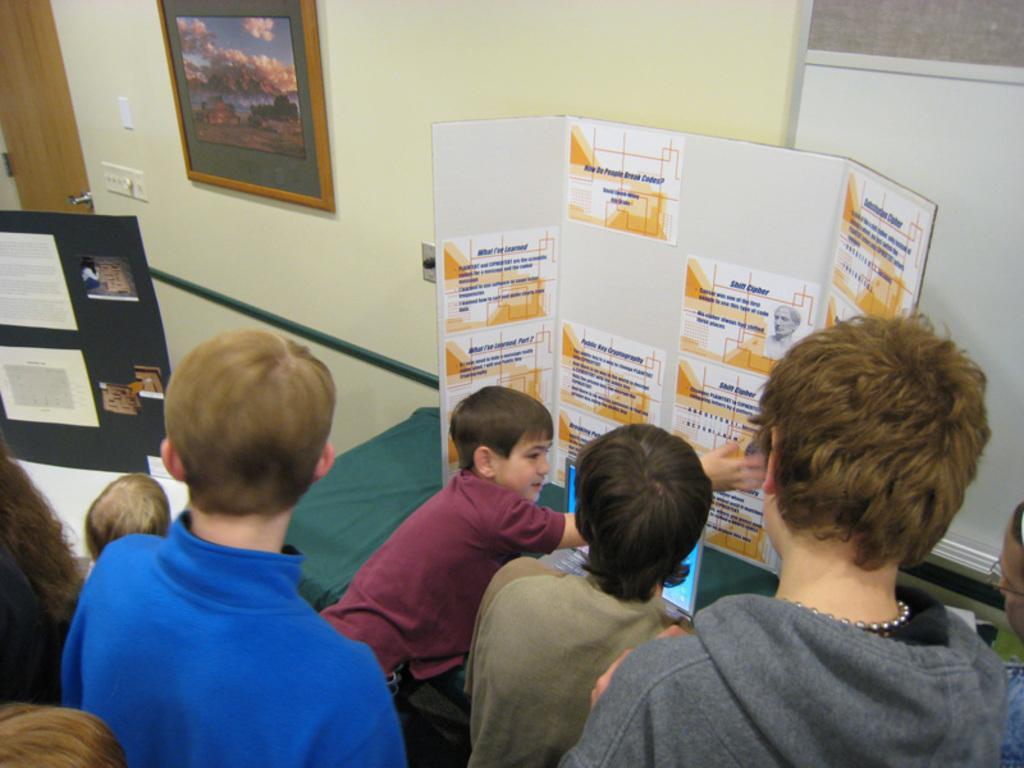Could you give a brief overview of what you see in this image? In the picture we can see a some children are standing and explaining something which is on the board with some information pamphlets on it and near to it, we can see a laptop is placed on the table and behind the children we can see some boys are standing and watching them and in the background we can see a wall with doors, switch board and some photo frame with some painting in it. 